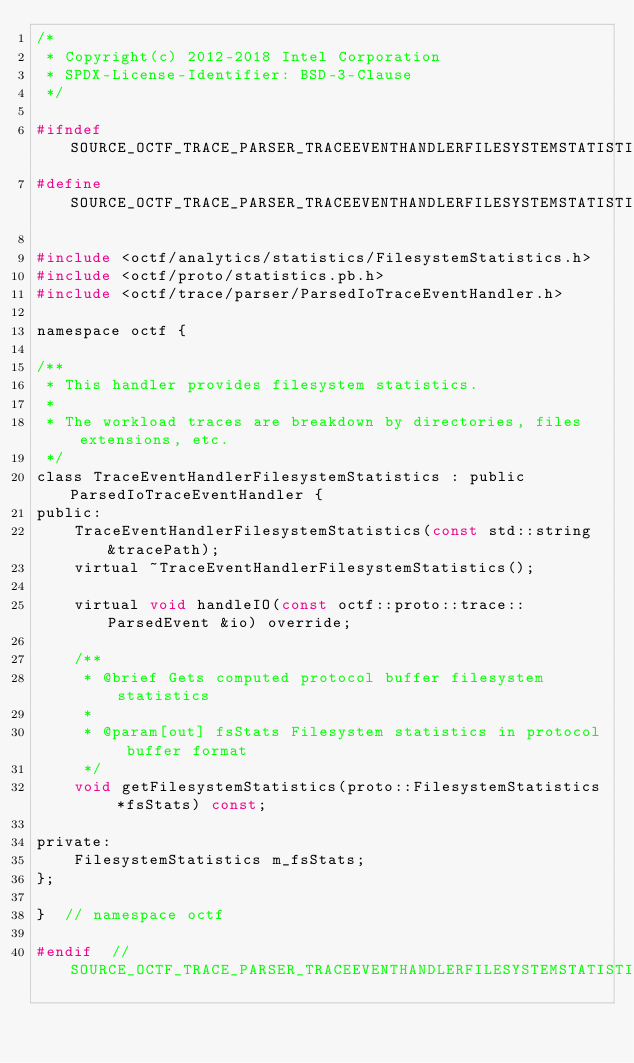<code> <loc_0><loc_0><loc_500><loc_500><_C_>/*
 * Copyright(c) 2012-2018 Intel Corporation
 * SPDX-License-Identifier: BSD-3-Clause
 */

#ifndef SOURCE_OCTF_TRACE_PARSER_TRACEEVENTHANDLERFILESYSTEMSTATISTICS_H
#define SOURCE_OCTF_TRACE_PARSER_TRACEEVENTHANDLERFILESYSTEMSTATISTICS_H

#include <octf/analytics/statistics/FilesystemStatistics.h>
#include <octf/proto/statistics.pb.h>
#include <octf/trace/parser/ParsedIoTraceEventHandler.h>

namespace octf {

/**
 * This handler provides filesystem statistics.
 *
 * The workload traces are breakdown by directories, files extensions, etc.
 */
class TraceEventHandlerFilesystemStatistics : public ParsedIoTraceEventHandler {
public:
    TraceEventHandlerFilesystemStatistics(const std::string &tracePath);
    virtual ~TraceEventHandlerFilesystemStatistics();

    virtual void handleIO(const octf::proto::trace::ParsedEvent &io) override;

    /**
     * @brief Gets computed protocol buffer filesystem statistics
     *
     * @param[out] fsStats Filesystem statistics in protocol buffer format
     */
    void getFilesystemStatistics(proto::FilesystemStatistics *fsStats) const;

private:
    FilesystemStatistics m_fsStats;
};

}  // namespace octf

#endif  // SOURCE_OCTF_TRACE_PARSER_TRACEEVENTHANDLERFILESYSTEMSTATISTICS_H
</code> 